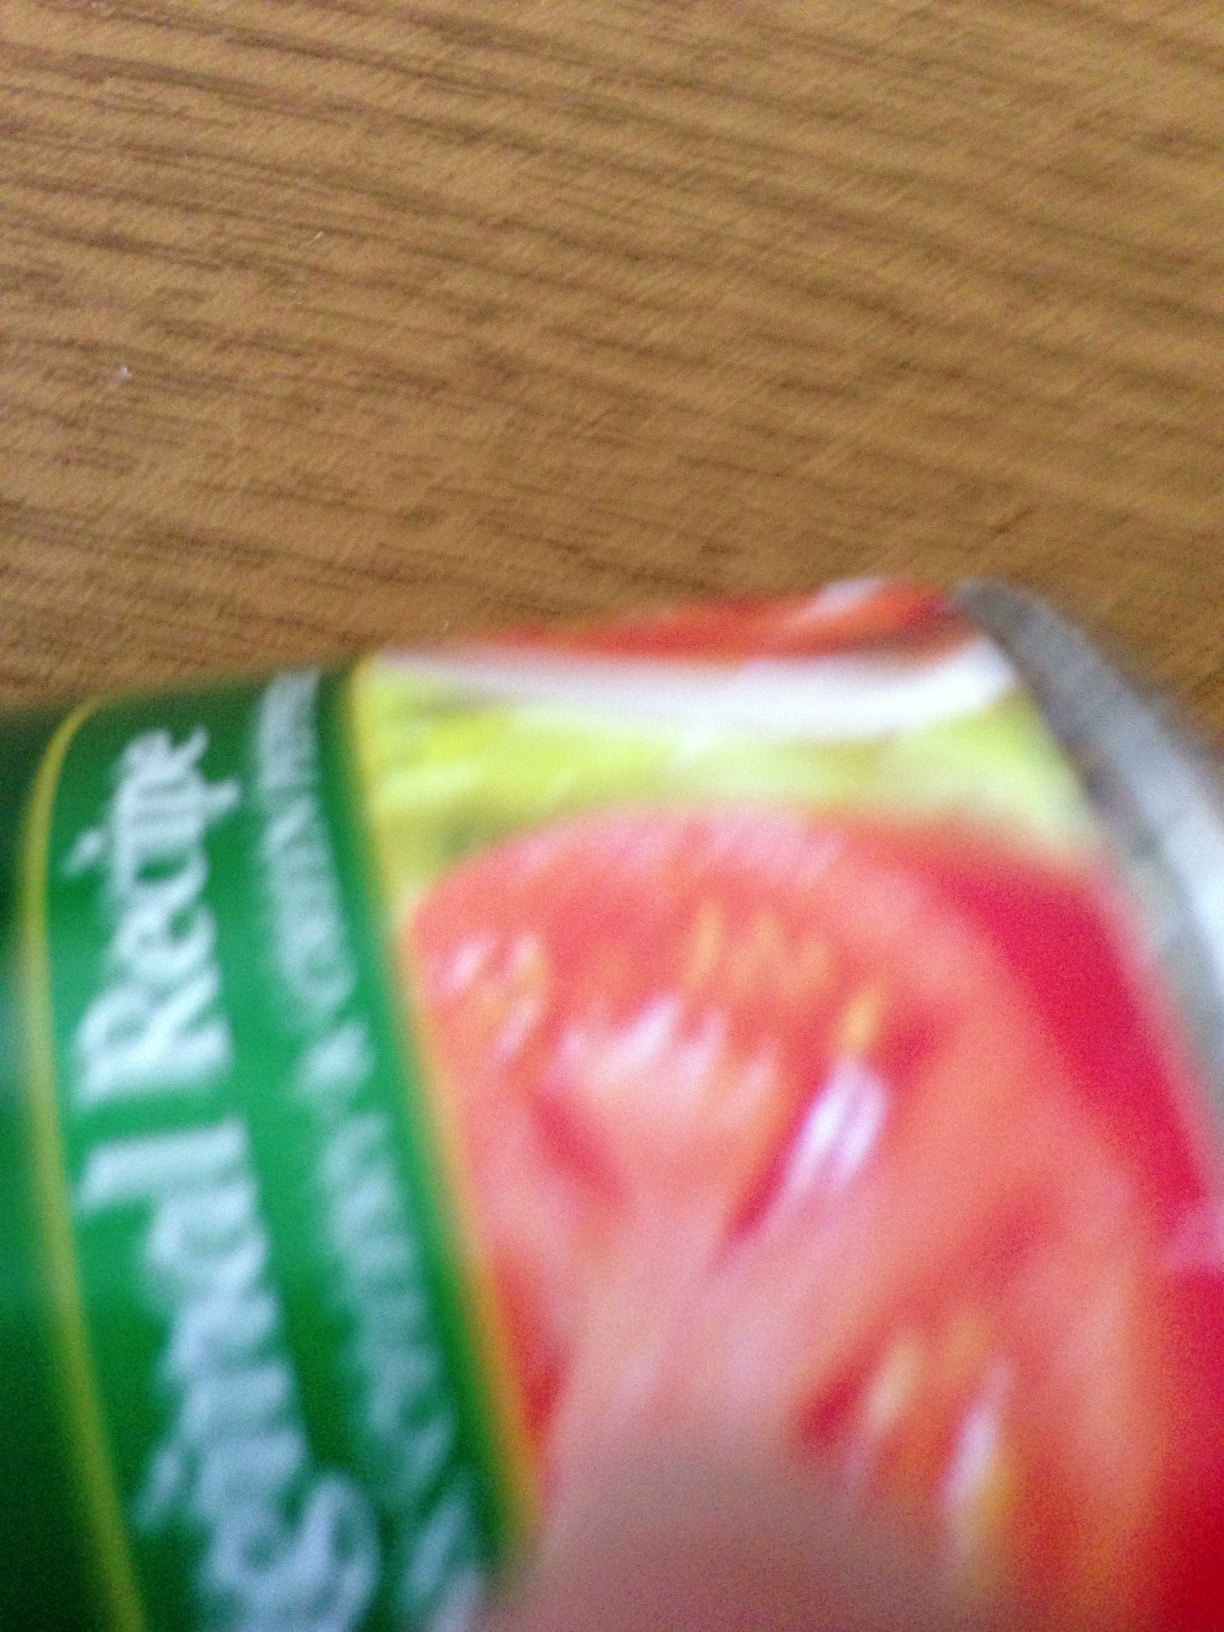Can you identify any visible text or logo on this product? The image is too blurred to read any text or identify logos clearly. For specific product information, clearer imagery or physical inspection would be beneficial. 